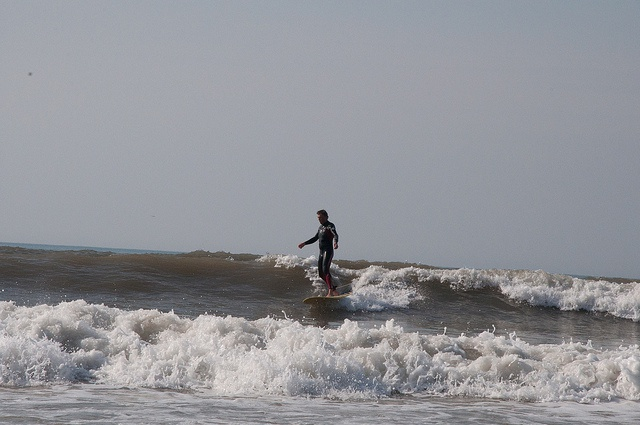Describe the objects in this image and their specific colors. I can see people in darkgray, black, gray, and maroon tones and surfboard in darkgray, black, and gray tones in this image. 